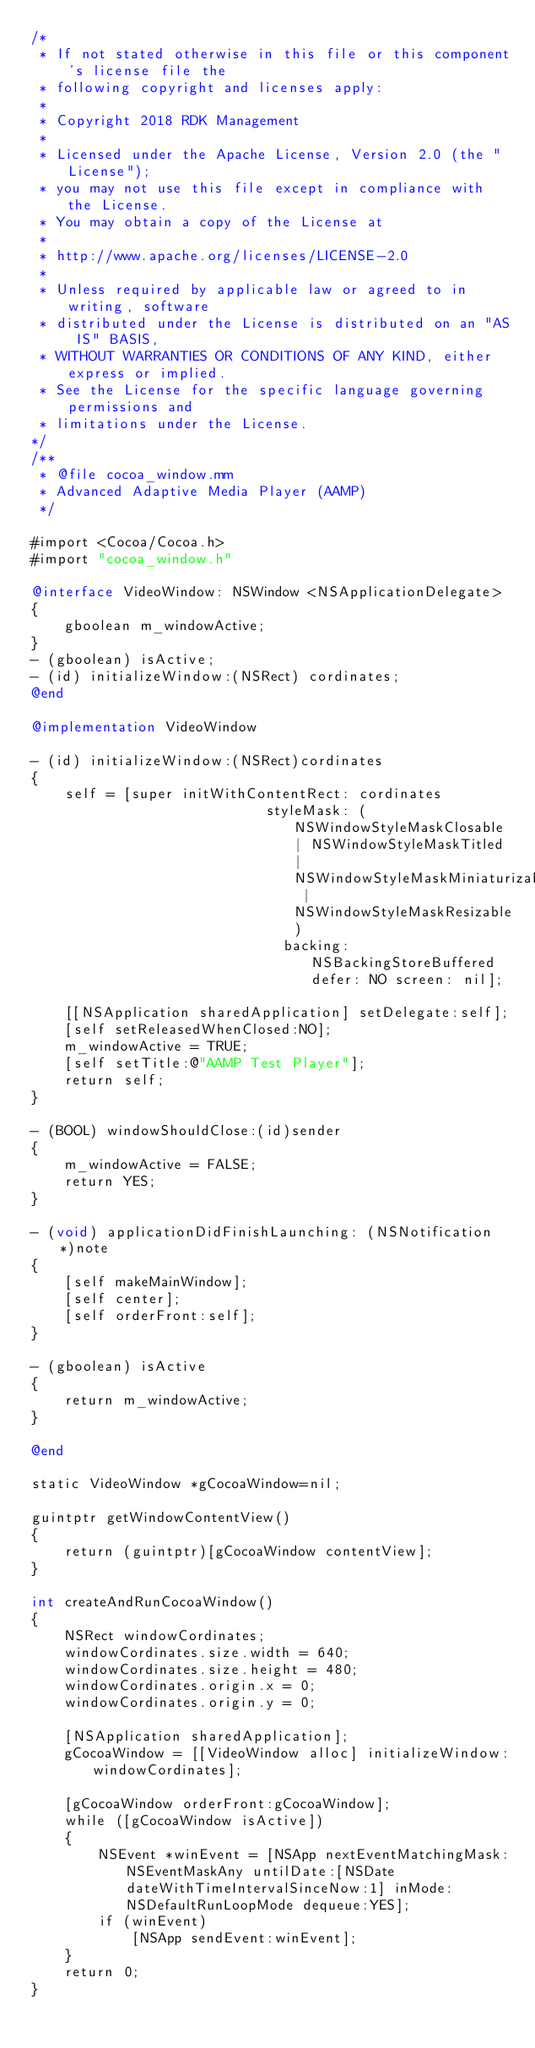Convert code to text. <code><loc_0><loc_0><loc_500><loc_500><_ObjectiveC_>/*
 * If not stated otherwise in this file or this component's license file the
 * following copyright and licenses apply:
 *
 * Copyright 2018 RDK Management
 *
 * Licensed under the Apache License, Version 2.0 (the "License");
 * you may not use this file except in compliance with the License.
 * You may obtain a copy of the License at
 *
 * http://www.apache.org/licenses/LICENSE-2.0
 *
 * Unless required by applicable law or agreed to in writing, software
 * distributed under the License is distributed on an "AS IS" BASIS,
 * WITHOUT WARRANTIES OR CONDITIONS OF ANY KIND, either express or implied.
 * See the License for the specific language governing permissions and
 * limitations under the License.
*/
/**
 * @file cocoa_window.mm
 * Advanced Adaptive Media Player (AAMP)
 */

#import <Cocoa/Cocoa.h>
#import "cocoa_window.h"

@interface VideoWindow: NSWindow <NSApplicationDelegate>
{
    gboolean m_windowActive;
}
- (gboolean) isActive;
- (id) initializeWindow:(NSRect) cordinates;
@end

@implementation VideoWindow

- (id) initializeWindow:(NSRect)cordinates
{
    self = [super initWithContentRect: cordinates
                            styleMask: (NSWindowStyleMaskClosable | NSWindowStyleMaskTitled | NSWindowStyleMaskMiniaturizable | NSWindowStyleMaskResizable)
                              backing: NSBackingStoreBuffered defer: NO screen: nil];

    [[NSApplication sharedApplication] setDelegate:self];
    [self setReleasedWhenClosed:NO];
    m_windowActive = TRUE;
    [self setTitle:@"AAMP Test Player"];
    return self;
}

- (BOOL) windowShouldClose:(id)sender
{
    m_windowActive = FALSE;
    return YES;
}

- (void) applicationDidFinishLaunching: (NSNotification *)note
{
    [self makeMainWindow];
    [self center];
    [self orderFront:self];
}

- (gboolean) isActive
{
    return m_windowActive;
}

@end

static VideoWindow *gCocoaWindow=nil;

guintptr getWindowContentView()
{
    return (guintptr)[gCocoaWindow contentView];
}

int createAndRunCocoaWindow()
{
    NSRect windowCordinates;
    windowCordinates.size.width = 640;
    windowCordinates.size.height = 480;
    windowCordinates.origin.x = 0;
    windowCordinates.origin.y = 0;

    [NSApplication sharedApplication];
    gCocoaWindow = [[VideoWindow alloc] initializeWindow:windowCordinates];

    [gCocoaWindow orderFront:gCocoaWindow];
    while ([gCocoaWindow isActive])
    {
        NSEvent *winEvent = [NSApp nextEventMatchingMask:NSEventMaskAny untilDate:[NSDate dateWithTimeIntervalSinceNow:1] inMode:NSDefaultRunLoopMode dequeue:YES];
        if (winEvent)
            [NSApp sendEvent:winEvent];
    }
    return 0;
}
</code> 